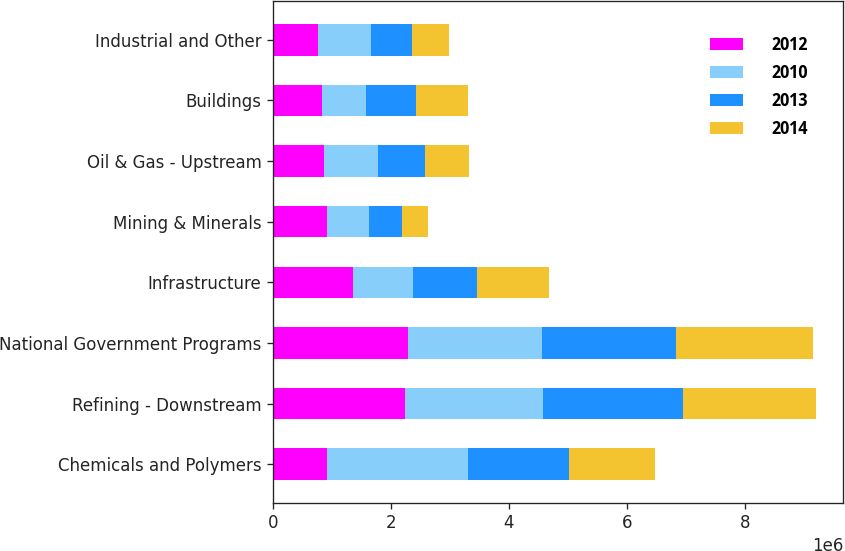Convert chart to OTSL. <chart><loc_0><loc_0><loc_500><loc_500><stacked_bar_chart><ecel><fcel>Chemicals and Polymers<fcel>Refining - Downstream<fcel>National Government Programs<fcel>Infrastructure<fcel>Mining & Minerals<fcel>Oil & Gas - Upstream<fcel>Buildings<fcel>Industrial and Other<nl><fcel>2012<fcel>918608<fcel>2.23934e+06<fcel>2.28212e+06<fcel>1.36157e+06<fcel>918608<fcel>863344<fcel>834122<fcel>758036<nl><fcel>2010<fcel>2.39114e+06<fcel>2.33739e+06<fcel>2.28453e+06<fcel>1.01586e+06<fcel>712320<fcel>915478<fcel>738404<fcel>899756<nl><fcel>2013<fcel>1.70472e+06<fcel>2.37975e+06<fcel>2.27261e+06<fcel>1.08565e+06<fcel>550134<fcel>790546<fcel>843938<fcel>690124<nl><fcel>2014<fcel>1.46112e+06<fcel>2.25609e+06<fcel>2.31324e+06<fcel>1.21963e+06<fcel>449194<fcel>753471<fcel>893528<fcel>630694<nl></chart> 